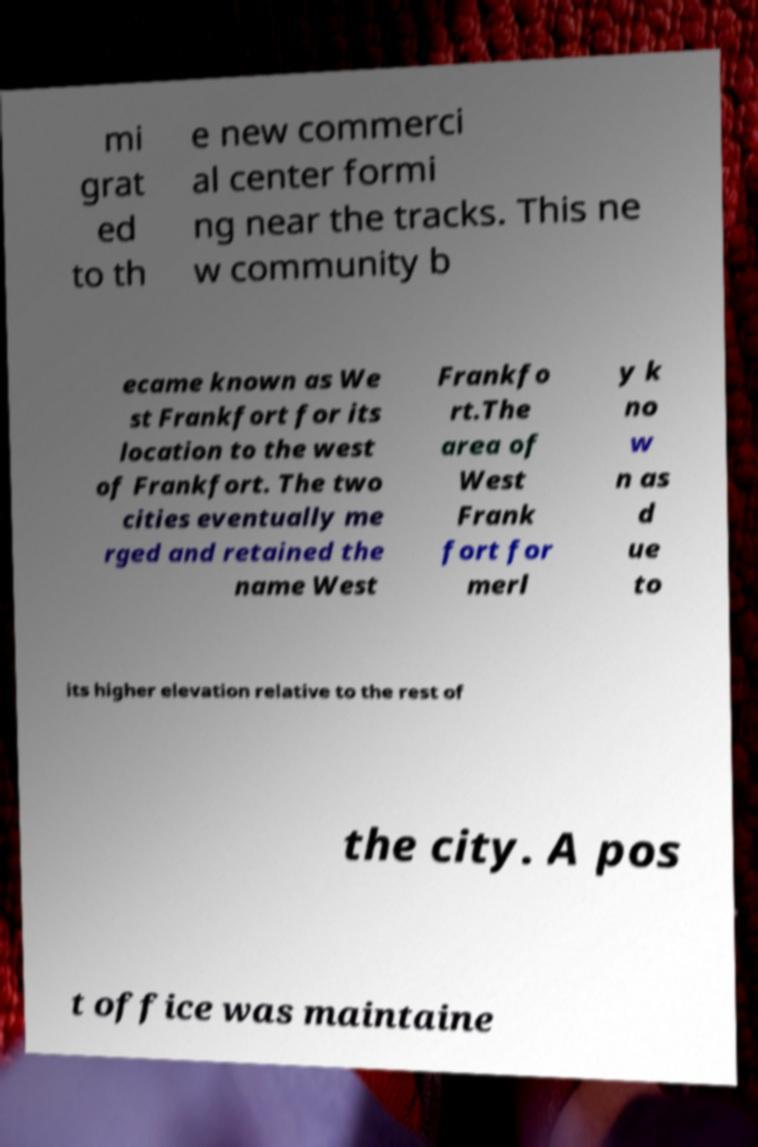Can you accurately transcribe the text from the provided image for me? mi grat ed to th e new commerci al center formi ng near the tracks. This ne w community b ecame known as We st Frankfort for its location to the west of Frankfort. The two cities eventually me rged and retained the name West Frankfo rt.The area of West Frank fort for merl y k no w n as d ue to its higher elevation relative to the rest of the city. A pos t office was maintaine 